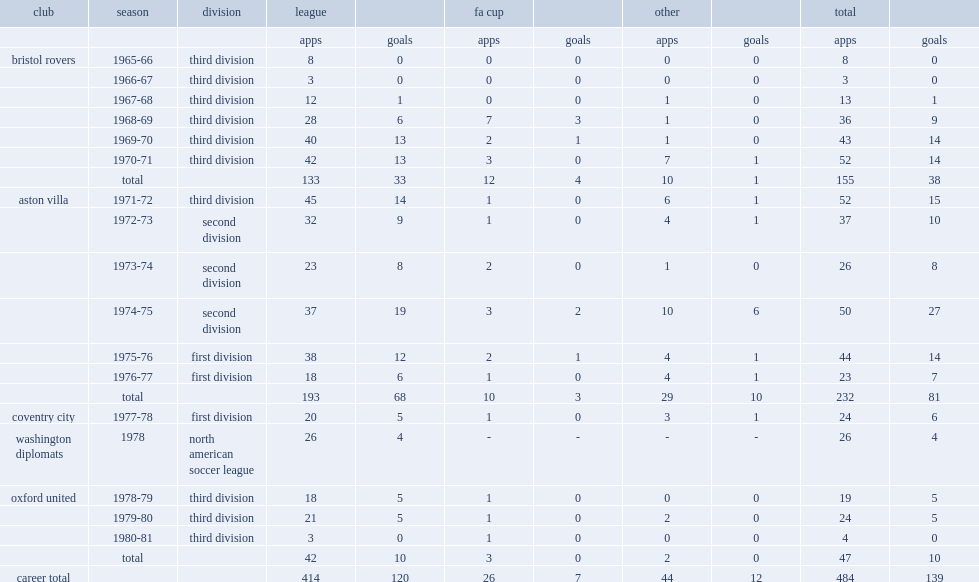Which club did graydon play for in 1965-66? Bristol rovers. 